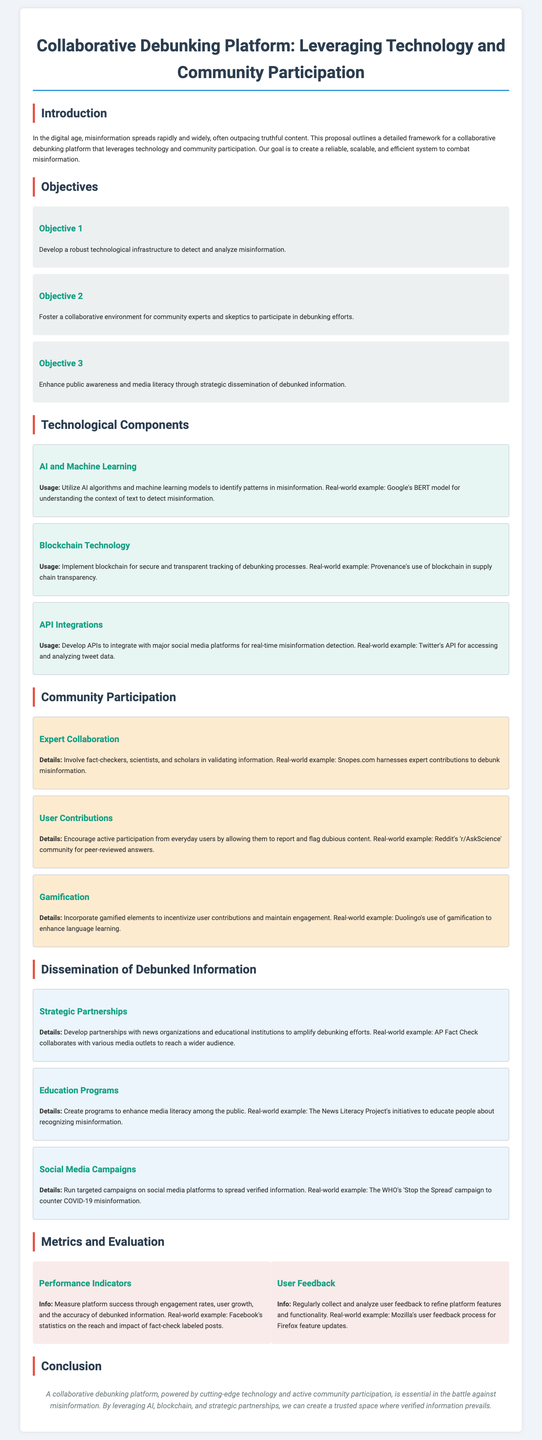What is the primary goal of the proposal? The primary goal outlined in the proposal is to create a reliable, scalable, and efficient system to combat misinformation.
Answer: To combat misinformation What technology does the proposal suggest for detecting misinformation? The proposal suggests utilizing AI algorithms and machine learning models to detect misinformation.
Answer: AI algorithms and machine learning models Which community participant is involved in validating information? The proposal mentions that fact-checkers, scientists, and scholars are involved in validating information.
Answer: Fact-checkers, scientists, and scholars What type of technology is proposed for secure tracking? The proposal states that blockchain technology is suggested for secure and transparent tracking of debunking processes.
Answer: Blockchain technology How many objectives are outlined in the proposal? The proposal outlines three objectives that guide its framework.
Answer: Three objectives What is an example of a social media campaign mentioned in the document? The document mentions the WHO's 'Stop the Spread' campaign as an example of a social media campaign.
Answer: WHO's 'Stop the Spread' campaign What method does the proposal suggest to measure platform success? The proposal suggests measuring success through engagement rates, user growth, and the accuracy of debunked information.
Answer: Engagement rates, user growth, and accuracy of debunked information What concept is used to keep users engaged in the platform? The proposal suggests that gamification is a concept used to incentivize user contributions and maintain engagement.
Answer: Gamification What type of partnerships does the proposal recommend for disseminating information? The proposal recommends developing partnerships with news organizations and educational institutions to amplify debunking efforts.
Answer: Partnerships with news organizations and educational institutions 